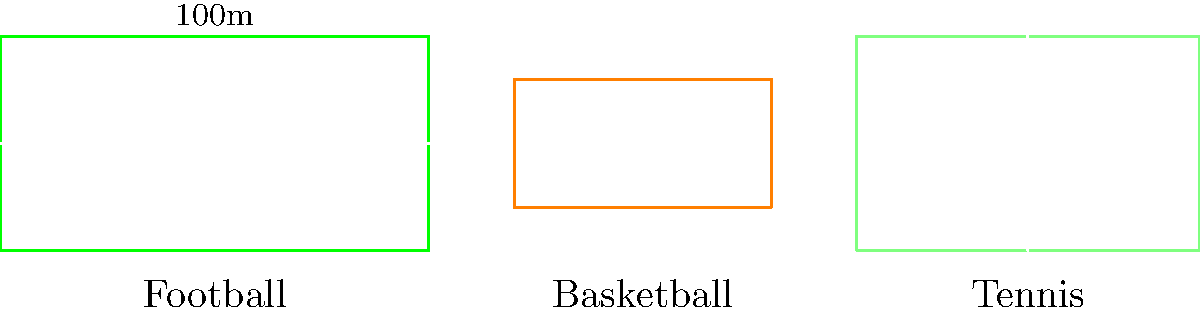Based on the visual representation of sports fields commonly found in Kanchanaburi, which sport's playing area has the largest perimeter? To determine which sport's playing area has the largest perimeter, we need to calculate the perimeter of each field:

1. Football field:
   Length = 100m, Width = 50m
   Perimeter = 2 * (100m + 50m) = 300m

2. Basketball court:
   Length = 60m, Width = 30m
   Perimeter = 2 * (60m + 30m) = 180m

3. Tennis court:
   Length = 80m, Width = 50m
   Perimeter = 2 * (80m + 50m) = 260m

Comparing the perimeters:
Football: 300m
Basketball: 180m
Tennis: 260m

The football field has the largest perimeter at 300m.
Answer: Football 